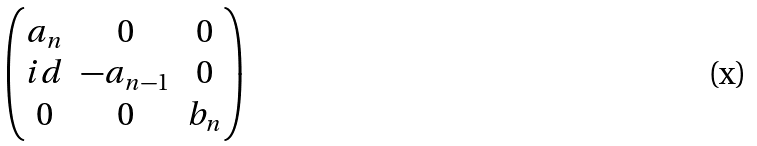Convert formula to latex. <formula><loc_0><loc_0><loc_500><loc_500>\begin{pmatrix} a _ { n } & 0 & 0 \\ i d & - a _ { n - 1 } & 0 \\ 0 & 0 & b _ { n } \end{pmatrix}</formula> 